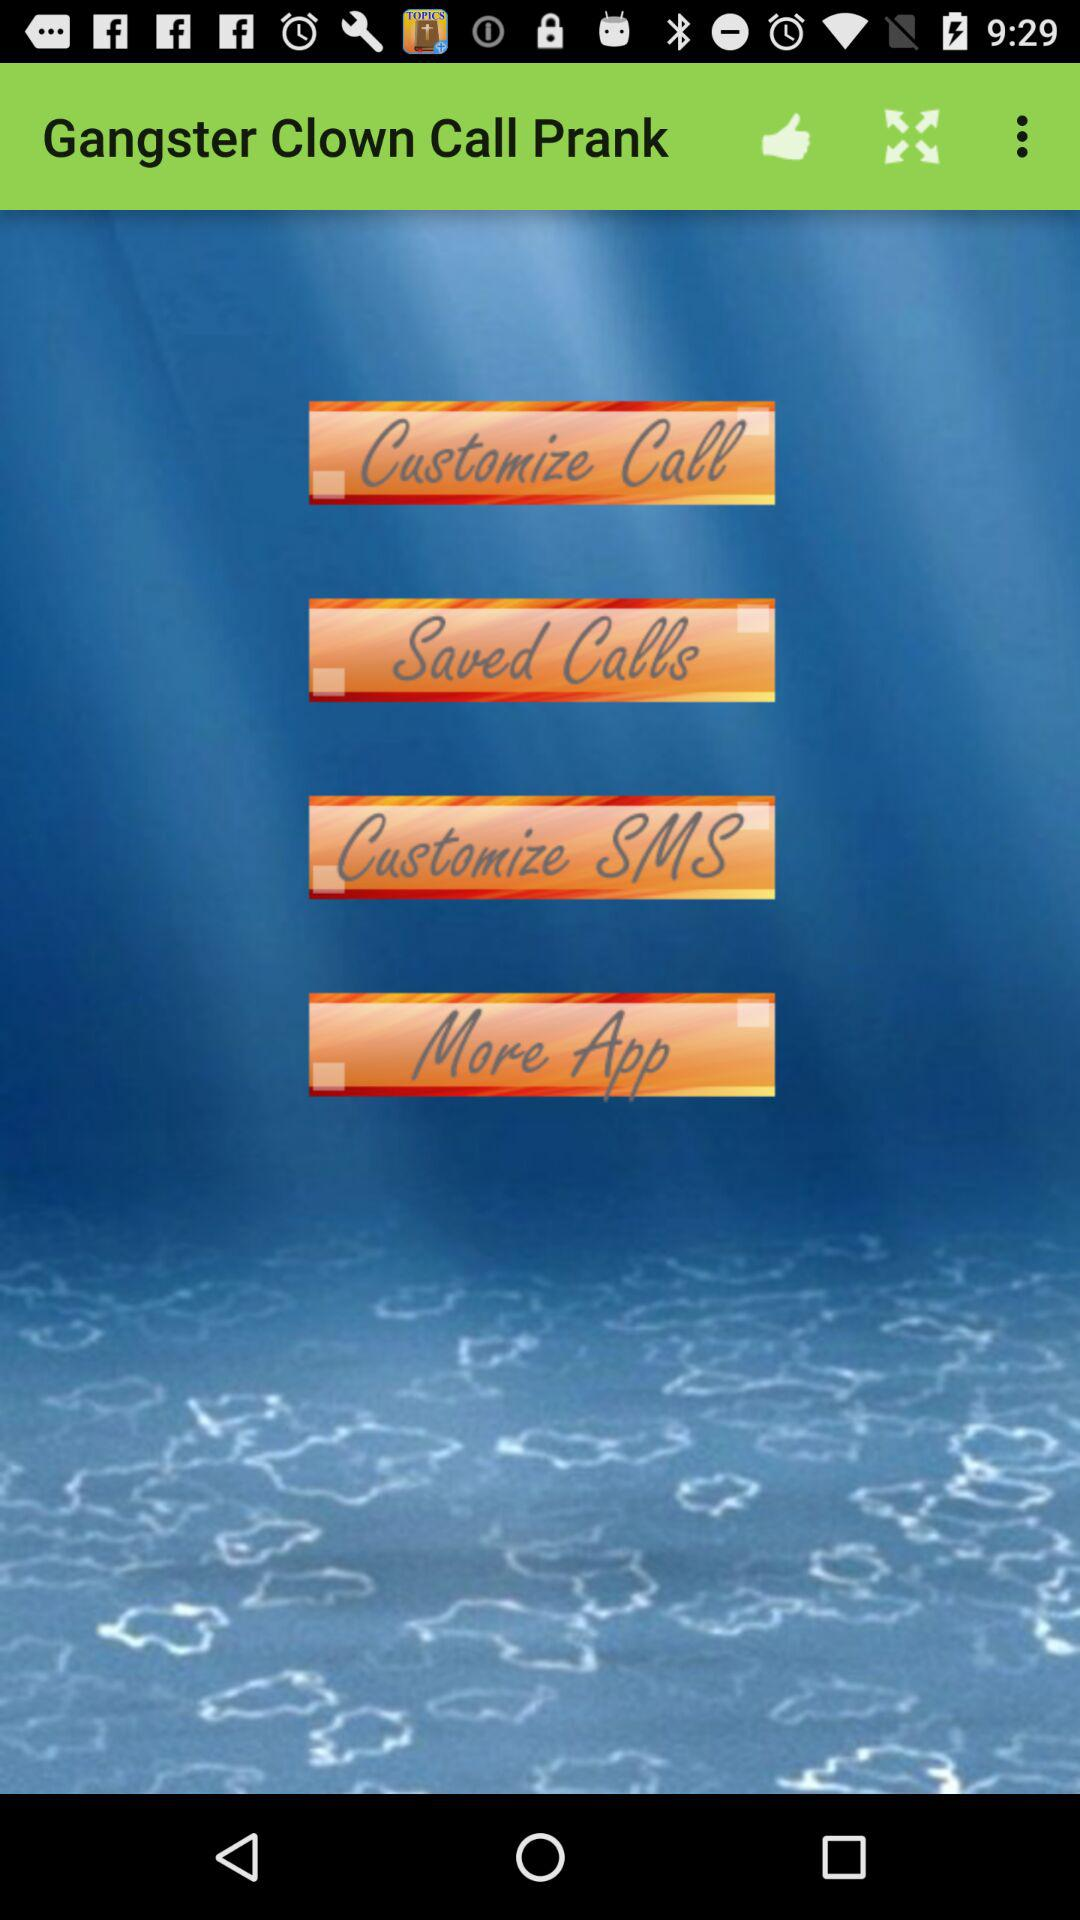What is the application name? The application name is "Gangster Clown Call Prank". 